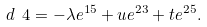Convert formula to latex. <formula><loc_0><loc_0><loc_500><loc_500>d \ 4 = - \lambda e ^ { 1 5 } + u e ^ { 2 3 } + t e ^ { 2 5 } .</formula> 